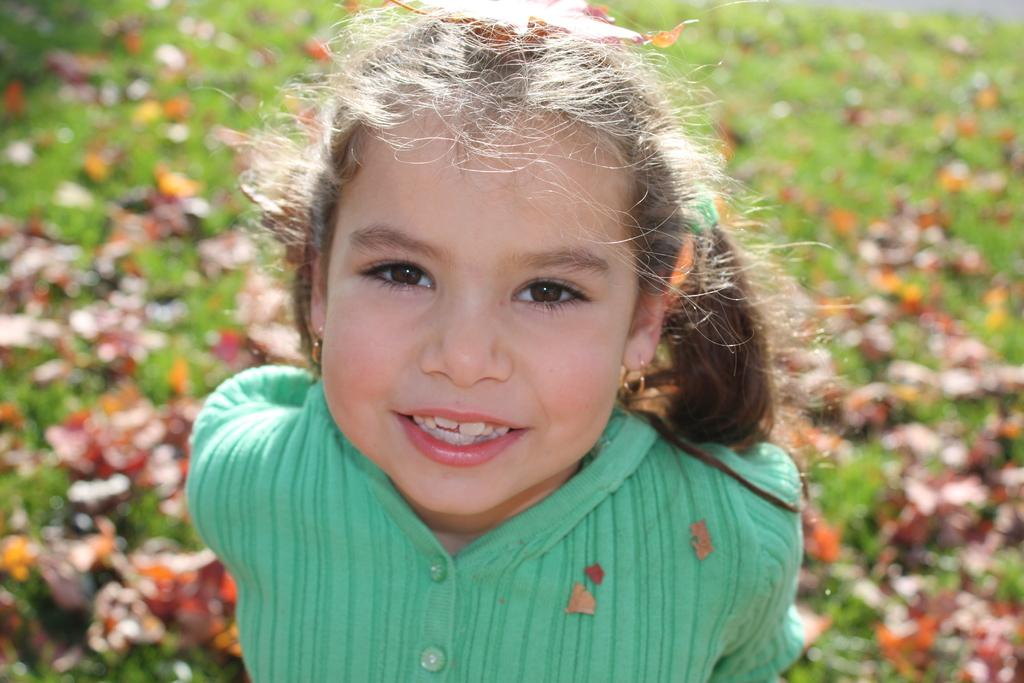Who is the main subject in the image? There is a girl in the image. What is the girl doing in the image? The girl is smiling. Can you describe the background of the image? The background of the image is blurry. What type of natural environment is visible in the image? There is grass visible in the background of the image. How many lawyers are present in the crowd in the image? There is no crowd or lawyer present in the image; it features a girl smiling in a blurry background with grass visible. 